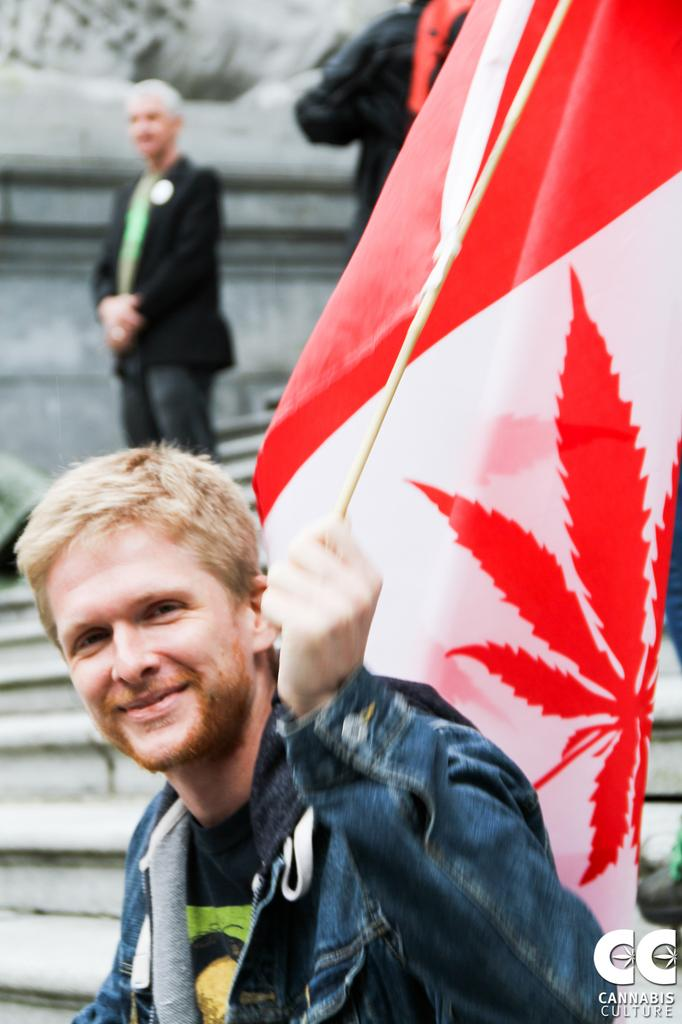Who is the main subject in the image? There is a man in the image. What is the man holding in his hand? The man is holding a flag in his hand. What is the man's facial expression? The man is smiling. Can you describe the people in the background of the image? There are two persons in the background of the image. What type of animal can be seen interacting with the man in the image? There is no animal present in the image; it only features the man holding a flag and smiling. 